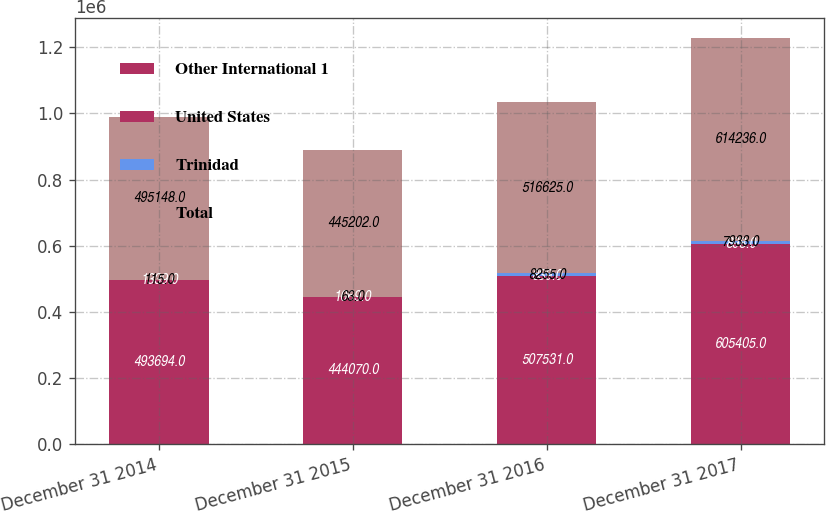Convert chart. <chart><loc_0><loc_0><loc_500><loc_500><stacked_bar_chart><ecel><fcel>December 31 2014<fcel>December 31 2015<fcel>December 31 2016<fcel>December 31 2017<nl><fcel>Other International 1<fcel>493694<fcel>444070<fcel>507531<fcel>605405<nl><fcel>United States<fcel>1339<fcel>1069<fcel>839<fcel>898<nl><fcel>Trinidad<fcel>115<fcel>63<fcel>8255<fcel>7933<nl><fcel>Total<fcel>495148<fcel>445202<fcel>516625<fcel>614236<nl></chart> 